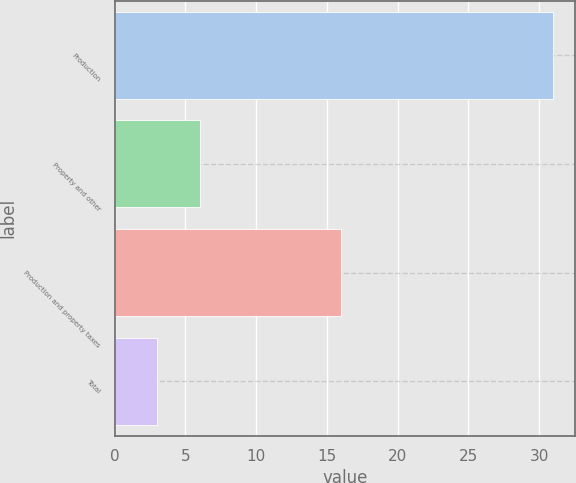Convert chart to OTSL. <chart><loc_0><loc_0><loc_500><loc_500><bar_chart><fcel>Production<fcel>Property and other<fcel>Production and property taxes<fcel>Total<nl><fcel>31<fcel>6<fcel>16<fcel>3.02<nl></chart> 